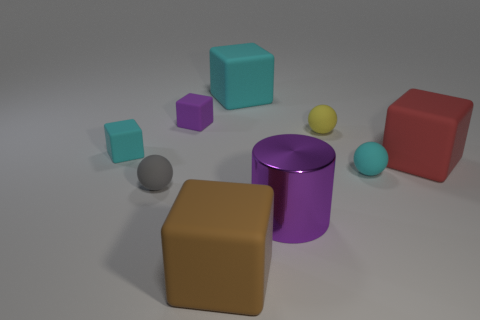Subtract all yellow balls. How many balls are left? 2 Add 1 large brown metal blocks. How many objects exist? 10 Subtract all cyan balls. How many balls are left? 2 Subtract all cylinders. How many objects are left? 8 Subtract all cyan cylinders. How many cyan cubes are left? 2 Subtract 3 cubes. How many cubes are left? 2 Subtract all small cyan spheres. Subtract all big cubes. How many objects are left? 5 Add 1 big matte cubes. How many big matte cubes are left? 4 Add 5 small blue metallic cylinders. How many small blue metallic cylinders exist? 5 Subtract 1 cyan balls. How many objects are left? 8 